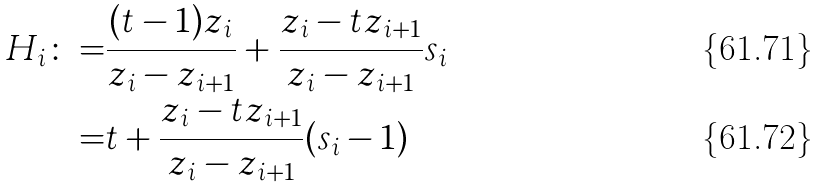Convert formula to latex. <formula><loc_0><loc_0><loc_500><loc_500>H _ { i } \colon = & \frac { ( t - 1 ) z _ { i } } { z _ { i } - z _ { i + 1 } } + \frac { z _ { i } - t z _ { i + 1 } } { z _ { i } - z _ { i + 1 } } s _ { i } \\ = & t + \frac { z _ { i } - t z _ { i + 1 } } { z _ { i } - z _ { i + 1 } } ( s _ { i } - 1 )</formula> 